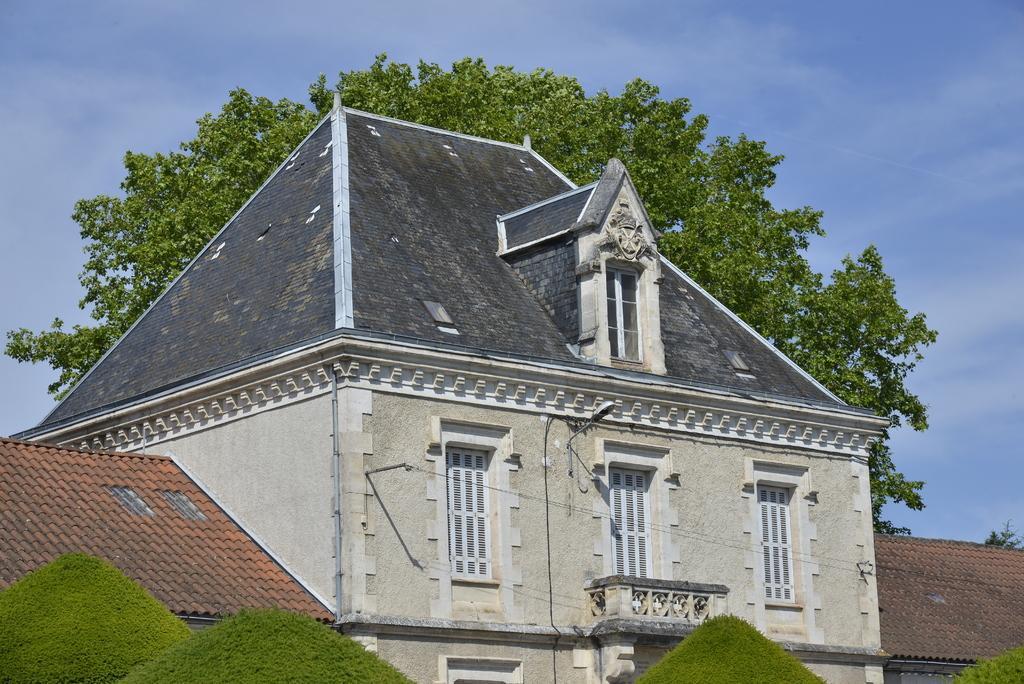Can you describe this image briefly? In this image I can see buildings in the center of the image and trees at the bottom of the image and another tree behind the building. At the top of the image I can see the sky.  